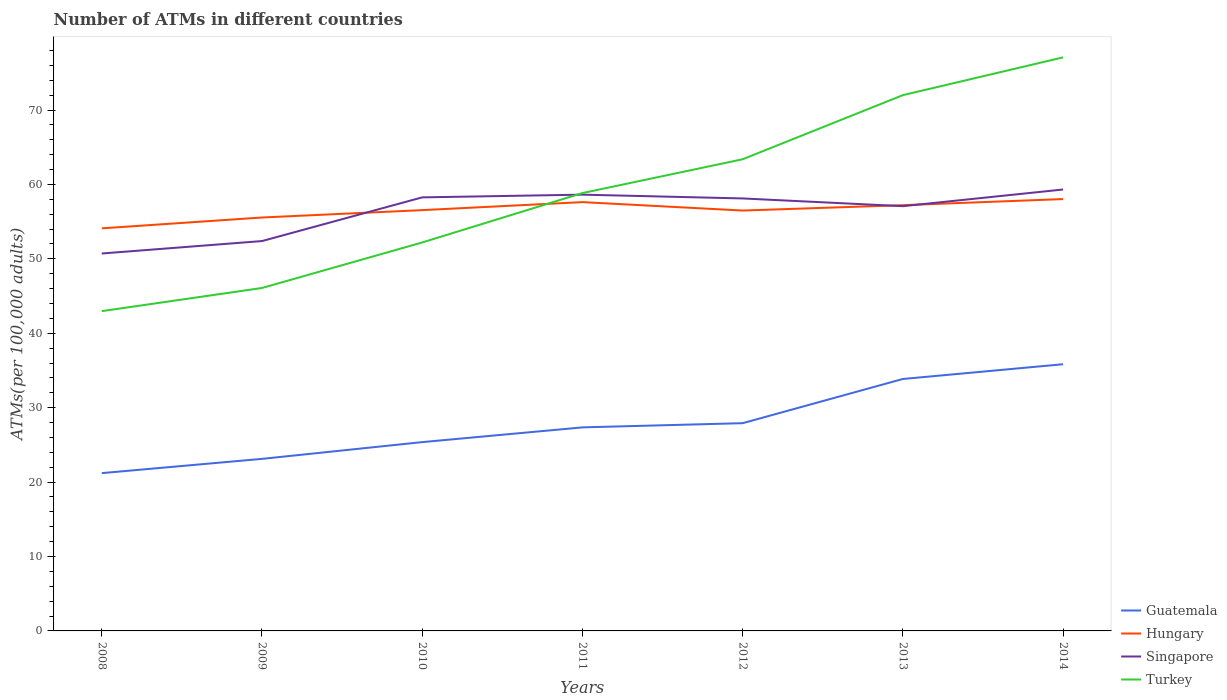How many different coloured lines are there?
Keep it short and to the point. 4. Is the number of lines equal to the number of legend labels?
Your answer should be very brief. Yes. Across all years, what is the maximum number of ATMs in Singapore?
Offer a very short reply. 50.72. In which year was the number of ATMs in Singapore maximum?
Ensure brevity in your answer.  2008. What is the total number of ATMs in Turkey in the graph?
Your answer should be compact. -19.8. What is the difference between the highest and the second highest number of ATMs in Hungary?
Keep it short and to the point. 3.93. Is the number of ATMs in Hungary strictly greater than the number of ATMs in Turkey over the years?
Provide a short and direct response. No. How many lines are there?
Keep it short and to the point. 4. How many years are there in the graph?
Give a very brief answer. 7. What is the difference between two consecutive major ticks on the Y-axis?
Offer a terse response. 10. Does the graph contain any zero values?
Give a very brief answer. No. Does the graph contain grids?
Your response must be concise. No. Where does the legend appear in the graph?
Provide a succinct answer. Bottom right. What is the title of the graph?
Keep it short and to the point. Number of ATMs in different countries. Does "Japan" appear as one of the legend labels in the graph?
Provide a succinct answer. No. What is the label or title of the Y-axis?
Your response must be concise. ATMs(per 100,0 adults). What is the ATMs(per 100,000 adults) of Guatemala in 2008?
Offer a terse response. 21.21. What is the ATMs(per 100,000 adults) in Hungary in 2008?
Your answer should be very brief. 54.1. What is the ATMs(per 100,000 adults) in Singapore in 2008?
Your answer should be compact. 50.72. What is the ATMs(per 100,000 adults) in Turkey in 2008?
Your answer should be very brief. 42.98. What is the ATMs(per 100,000 adults) in Guatemala in 2009?
Make the answer very short. 23.12. What is the ATMs(per 100,000 adults) in Hungary in 2009?
Offer a terse response. 55.56. What is the ATMs(per 100,000 adults) in Singapore in 2009?
Give a very brief answer. 52.39. What is the ATMs(per 100,000 adults) of Turkey in 2009?
Make the answer very short. 46.09. What is the ATMs(per 100,000 adults) of Guatemala in 2010?
Ensure brevity in your answer.  25.37. What is the ATMs(per 100,000 adults) of Hungary in 2010?
Make the answer very short. 56.55. What is the ATMs(per 100,000 adults) in Singapore in 2010?
Your response must be concise. 58.27. What is the ATMs(per 100,000 adults) of Turkey in 2010?
Ensure brevity in your answer.  52.21. What is the ATMs(per 100,000 adults) of Guatemala in 2011?
Ensure brevity in your answer.  27.35. What is the ATMs(per 100,000 adults) of Hungary in 2011?
Provide a short and direct response. 57.63. What is the ATMs(per 100,000 adults) of Singapore in 2011?
Your answer should be compact. 58.63. What is the ATMs(per 100,000 adults) in Turkey in 2011?
Your answer should be very brief. 58.84. What is the ATMs(per 100,000 adults) of Guatemala in 2012?
Keep it short and to the point. 27.92. What is the ATMs(per 100,000 adults) of Hungary in 2012?
Provide a short and direct response. 56.49. What is the ATMs(per 100,000 adults) of Singapore in 2012?
Your response must be concise. 58.12. What is the ATMs(per 100,000 adults) in Turkey in 2012?
Offer a very short reply. 63.39. What is the ATMs(per 100,000 adults) in Guatemala in 2013?
Ensure brevity in your answer.  33.86. What is the ATMs(per 100,000 adults) of Hungary in 2013?
Provide a short and direct response. 57.22. What is the ATMs(per 100,000 adults) in Singapore in 2013?
Offer a very short reply. 57.08. What is the ATMs(per 100,000 adults) of Turkey in 2013?
Ensure brevity in your answer.  72. What is the ATMs(per 100,000 adults) in Guatemala in 2014?
Your response must be concise. 35.84. What is the ATMs(per 100,000 adults) in Hungary in 2014?
Provide a succinct answer. 58.04. What is the ATMs(per 100,000 adults) of Singapore in 2014?
Your answer should be compact. 59.32. What is the ATMs(per 100,000 adults) in Turkey in 2014?
Offer a very short reply. 77.08. Across all years, what is the maximum ATMs(per 100,000 adults) in Guatemala?
Your response must be concise. 35.84. Across all years, what is the maximum ATMs(per 100,000 adults) in Hungary?
Ensure brevity in your answer.  58.04. Across all years, what is the maximum ATMs(per 100,000 adults) in Singapore?
Your answer should be very brief. 59.32. Across all years, what is the maximum ATMs(per 100,000 adults) of Turkey?
Your response must be concise. 77.08. Across all years, what is the minimum ATMs(per 100,000 adults) of Guatemala?
Ensure brevity in your answer.  21.21. Across all years, what is the minimum ATMs(per 100,000 adults) in Hungary?
Provide a succinct answer. 54.1. Across all years, what is the minimum ATMs(per 100,000 adults) in Singapore?
Offer a very short reply. 50.72. Across all years, what is the minimum ATMs(per 100,000 adults) of Turkey?
Provide a short and direct response. 42.98. What is the total ATMs(per 100,000 adults) in Guatemala in the graph?
Offer a terse response. 194.68. What is the total ATMs(per 100,000 adults) in Hungary in the graph?
Your response must be concise. 395.59. What is the total ATMs(per 100,000 adults) of Singapore in the graph?
Make the answer very short. 394.54. What is the total ATMs(per 100,000 adults) of Turkey in the graph?
Ensure brevity in your answer.  412.59. What is the difference between the ATMs(per 100,000 adults) in Guatemala in 2008 and that in 2009?
Offer a terse response. -1.92. What is the difference between the ATMs(per 100,000 adults) in Hungary in 2008 and that in 2009?
Give a very brief answer. -1.46. What is the difference between the ATMs(per 100,000 adults) of Singapore in 2008 and that in 2009?
Make the answer very short. -1.67. What is the difference between the ATMs(per 100,000 adults) in Turkey in 2008 and that in 2009?
Make the answer very short. -3.11. What is the difference between the ATMs(per 100,000 adults) of Guatemala in 2008 and that in 2010?
Offer a very short reply. -4.17. What is the difference between the ATMs(per 100,000 adults) of Hungary in 2008 and that in 2010?
Offer a very short reply. -2.45. What is the difference between the ATMs(per 100,000 adults) of Singapore in 2008 and that in 2010?
Ensure brevity in your answer.  -7.54. What is the difference between the ATMs(per 100,000 adults) in Turkey in 2008 and that in 2010?
Offer a terse response. -9.23. What is the difference between the ATMs(per 100,000 adults) of Guatemala in 2008 and that in 2011?
Provide a short and direct response. -6.15. What is the difference between the ATMs(per 100,000 adults) in Hungary in 2008 and that in 2011?
Provide a short and direct response. -3.52. What is the difference between the ATMs(per 100,000 adults) of Singapore in 2008 and that in 2011?
Provide a succinct answer. -7.91. What is the difference between the ATMs(per 100,000 adults) in Turkey in 2008 and that in 2011?
Make the answer very short. -15.87. What is the difference between the ATMs(per 100,000 adults) of Guatemala in 2008 and that in 2012?
Offer a very short reply. -6.71. What is the difference between the ATMs(per 100,000 adults) in Hungary in 2008 and that in 2012?
Give a very brief answer. -2.39. What is the difference between the ATMs(per 100,000 adults) of Singapore in 2008 and that in 2012?
Your answer should be very brief. -7.4. What is the difference between the ATMs(per 100,000 adults) of Turkey in 2008 and that in 2012?
Your answer should be very brief. -20.41. What is the difference between the ATMs(per 100,000 adults) in Guatemala in 2008 and that in 2013?
Ensure brevity in your answer.  -12.65. What is the difference between the ATMs(per 100,000 adults) in Hungary in 2008 and that in 2013?
Offer a very short reply. -3.11. What is the difference between the ATMs(per 100,000 adults) in Singapore in 2008 and that in 2013?
Keep it short and to the point. -6.36. What is the difference between the ATMs(per 100,000 adults) in Turkey in 2008 and that in 2013?
Your answer should be very brief. -29.03. What is the difference between the ATMs(per 100,000 adults) in Guatemala in 2008 and that in 2014?
Ensure brevity in your answer.  -14.63. What is the difference between the ATMs(per 100,000 adults) in Hungary in 2008 and that in 2014?
Your response must be concise. -3.93. What is the difference between the ATMs(per 100,000 adults) in Singapore in 2008 and that in 2014?
Offer a terse response. -8.6. What is the difference between the ATMs(per 100,000 adults) of Turkey in 2008 and that in 2014?
Offer a very short reply. -34.11. What is the difference between the ATMs(per 100,000 adults) of Guatemala in 2009 and that in 2010?
Offer a terse response. -2.25. What is the difference between the ATMs(per 100,000 adults) of Hungary in 2009 and that in 2010?
Offer a very short reply. -0.99. What is the difference between the ATMs(per 100,000 adults) in Singapore in 2009 and that in 2010?
Offer a terse response. -5.87. What is the difference between the ATMs(per 100,000 adults) of Turkey in 2009 and that in 2010?
Give a very brief answer. -6.12. What is the difference between the ATMs(per 100,000 adults) of Guatemala in 2009 and that in 2011?
Provide a short and direct response. -4.23. What is the difference between the ATMs(per 100,000 adults) in Hungary in 2009 and that in 2011?
Offer a terse response. -2.07. What is the difference between the ATMs(per 100,000 adults) of Singapore in 2009 and that in 2011?
Keep it short and to the point. -6.24. What is the difference between the ATMs(per 100,000 adults) in Turkey in 2009 and that in 2011?
Give a very brief answer. -12.75. What is the difference between the ATMs(per 100,000 adults) of Guatemala in 2009 and that in 2012?
Your answer should be compact. -4.8. What is the difference between the ATMs(per 100,000 adults) of Hungary in 2009 and that in 2012?
Provide a short and direct response. -0.93. What is the difference between the ATMs(per 100,000 adults) in Singapore in 2009 and that in 2012?
Provide a succinct answer. -5.73. What is the difference between the ATMs(per 100,000 adults) of Turkey in 2009 and that in 2012?
Your answer should be very brief. -17.3. What is the difference between the ATMs(per 100,000 adults) of Guatemala in 2009 and that in 2013?
Offer a very short reply. -10.74. What is the difference between the ATMs(per 100,000 adults) in Hungary in 2009 and that in 2013?
Give a very brief answer. -1.66. What is the difference between the ATMs(per 100,000 adults) of Singapore in 2009 and that in 2013?
Keep it short and to the point. -4.69. What is the difference between the ATMs(per 100,000 adults) in Turkey in 2009 and that in 2013?
Your answer should be compact. -25.91. What is the difference between the ATMs(per 100,000 adults) of Guatemala in 2009 and that in 2014?
Ensure brevity in your answer.  -12.72. What is the difference between the ATMs(per 100,000 adults) in Hungary in 2009 and that in 2014?
Your answer should be compact. -2.48. What is the difference between the ATMs(per 100,000 adults) in Singapore in 2009 and that in 2014?
Offer a very short reply. -6.93. What is the difference between the ATMs(per 100,000 adults) in Turkey in 2009 and that in 2014?
Your response must be concise. -30.99. What is the difference between the ATMs(per 100,000 adults) in Guatemala in 2010 and that in 2011?
Provide a succinct answer. -1.98. What is the difference between the ATMs(per 100,000 adults) in Hungary in 2010 and that in 2011?
Your answer should be compact. -1.08. What is the difference between the ATMs(per 100,000 adults) in Singapore in 2010 and that in 2011?
Your answer should be very brief. -0.36. What is the difference between the ATMs(per 100,000 adults) in Turkey in 2010 and that in 2011?
Give a very brief answer. -6.64. What is the difference between the ATMs(per 100,000 adults) in Guatemala in 2010 and that in 2012?
Your response must be concise. -2.55. What is the difference between the ATMs(per 100,000 adults) of Hungary in 2010 and that in 2012?
Make the answer very short. 0.06. What is the difference between the ATMs(per 100,000 adults) in Singapore in 2010 and that in 2012?
Ensure brevity in your answer.  0.14. What is the difference between the ATMs(per 100,000 adults) in Turkey in 2010 and that in 2012?
Offer a terse response. -11.18. What is the difference between the ATMs(per 100,000 adults) in Guatemala in 2010 and that in 2013?
Provide a short and direct response. -8.49. What is the difference between the ATMs(per 100,000 adults) of Hungary in 2010 and that in 2013?
Offer a very short reply. -0.67. What is the difference between the ATMs(per 100,000 adults) of Singapore in 2010 and that in 2013?
Your answer should be compact. 1.18. What is the difference between the ATMs(per 100,000 adults) of Turkey in 2010 and that in 2013?
Ensure brevity in your answer.  -19.8. What is the difference between the ATMs(per 100,000 adults) in Guatemala in 2010 and that in 2014?
Offer a very short reply. -10.47. What is the difference between the ATMs(per 100,000 adults) of Hungary in 2010 and that in 2014?
Provide a succinct answer. -1.49. What is the difference between the ATMs(per 100,000 adults) of Singapore in 2010 and that in 2014?
Offer a terse response. -1.06. What is the difference between the ATMs(per 100,000 adults) in Turkey in 2010 and that in 2014?
Offer a terse response. -24.88. What is the difference between the ATMs(per 100,000 adults) in Guatemala in 2011 and that in 2012?
Keep it short and to the point. -0.56. What is the difference between the ATMs(per 100,000 adults) in Hungary in 2011 and that in 2012?
Offer a very short reply. 1.13. What is the difference between the ATMs(per 100,000 adults) of Singapore in 2011 and that in 2012?
Your response must be concise. 0.51. What is the difference between the ATMs(per 100,000 adults) in Turkey in 2011 and that in 2012?
Give a very brief answer. -4.54. What is the difference between the ATMs(per 100,000 adults) in Guatemala in 2011 and that in 2013?
Provide a short and direct response. -6.5. What is the difference between the ATMs(per 100,000 adults) in Hungary in 2011 and that in 2013?
Give a very brief answer. 0.41. What is the difference between the ATMs(per 100,000 adults) in Singapore in 2011 and that in 2013?
Make the answer very short. 1.55. What is the difference between the ATMs(per 100,000 adults) in Turkey in 2011 and that in 2013?
Keep it short and to the point. -13.16. What is the difference between the ATMs(per 100,000 adults) of Guatemala in 2011 and that in 2014?
Give a very brief answer. -8.49. What is the difference between the ATMs(per 100,000 adults) in Hungary in 2011 and that in 2014?
Keep it short and to the point. -0.41. What is the difference between the ATMs(per 100,000 adults) in Singapore in 2011 and that in 2014?
Your answer should be compact. -0.69. What is the difference between the ATMs(per 100,000 adults) in Turkey in 2011 and that in 2014?
Make the answer very short. -18.24. What is the difference between the ATMs(per 100,000 adults) in Guatemala in 2012 and that in 2013?
Make the answer very short. -5.94. What is the difference between the ATMs(per 100,000 adults) of Hungary in 2012 and that in 2013?
Offer a terse response. -0.72. What is the difference between the ATMs(per 100,000 adults) in Singapore in 2012 and that in 2013?
Offer a very short reply. 1.04. What is the difference between the ATMs(per 100,000 adults) of Turkey in 2012 and that in 2013?
Your answer should be compact. -8.62. What is the difference between the ATMs(per 100,000 adults) of Guatemala in 2012 and that in 2014?
Give a very brief answer. -7.92. What is the difference between the ATMs(per 100,000 adults) of Hungary in 2012 and that in 2014?
Provide a succinct answer. -1.54. What is the difference between the ATMs(per 100,000 adults) of Singapore in 2012 and that in 2014?
Offer a terse response. -1.2. What is the difference between the ATMs(per 100,000 adults) of Turkey in 2012 and that in 2014?
Offer a very short reply. -13.69. What is the difference between the ATMs(per 100,000 adults) of Guatemala in 2013 and that in 2014?
Give a very brief answer. -1.98. What is the difference between the ATMs(per 100,000 adults) of Hungary in 2013 and that in 2014?
Your answer should be very brief. -0.82. What is the difference between the ATMs(per 100,000 adults) of Singapore in 2013 and that in 2014?
Offer a very short reply. -2.24. What is the difference between the ATMs(per 100,000 adults) of Turkey in 2013 and that in 2014?
Provide a succinct answer. -5.08. What is the difference between the ATMs(per 100,000 adults) in Guatemala in 2008 and the ATMs(per 100,000 adults) in Hungary in 2009?
Keep it short and to the point. -34.35. What is the difference between the ATMs(per 100,000 adults) in Guatemala in 2008 and the ATMs(per 100,000 adults) in Singapore in 2009?
Your answer should be very brief. -31.19. What is the difference between the ATMs(per 100,000 adults) in Guatemala in 2008 and the ATMs(per 100,000 adults) in Turkey in 2009?
Give a very brief answer. -24.88. What is the difference between the ATMs(per 100,000 adults) in Hungary in 2008 and the ATMs(per 100,000 adults) in Singapore in 2009?
Make the answer very short. 1.71. What is the difference between the ATMs(per 100,000 adults) of Hungary in 2008 and the ATMs(per 100,000 adults) of Turkey in 2009?
Your answer should be very brief. 8.01. What is the difference between the ATMs(per 100,000 adults) in Singapore in 2008 and the ATMs(per 100,000 adults) in Turkey in 2009?
Your answer should be compact. 4.63. What is the difference between the ATMs(per 100,000 adults) in Guatemala in 2008 and the ATMs(per 100,000 adults) in Hungary in 2010?
Your response must be concise. -35.34. What is the difference between the ATMs(per 100,000 adults) in Guatemala in 2008 and the ATMs(per 100,000 adults) in Singapore in 2010?
Offer a very short reply. -37.06. What is the difference between the ATMs(per 100,000 adults) of Guatemala in 2008 and the ATMs(per 100,000 adults) of Turkey in 2010?
Offer a very short reply. -31. What is the difference between the ATMs(per 100,000 adults) of Hungary in 2008 and the ATMs(per 100,000 adults) of Singapore in 2010?
Offer a very short reply. -4.16. What is the difference between the ATMs(per 100,000 adults) of Hungary in 2008 and the ATMs(per 100,000 adults) of Turkey in 2010?
Keep it short and to the point. 1.9. What is the difference between the ATMs(per 100,000 adults) of Singapore in 2008 and the ATMs(per 100,000 adults) of Turkey in 2010?
Offer a very short reply. -1.48. What is the difference between the ATMs(per 100,000 adults) of Guatemala in 2008 and the ATMs(per 100,000 adults) of Hungary in 2011?
Your answer should be compact. -36.42. What is the difference between the ATMs(per 100,000 adults) of Guatemala in 2008 and the ATMs(per 100,000 adults) of Singapore in 2011?
Your answer should be very brief. -37.42. What is the difference between the ATMs(per 100,000 adults) of Guatemala in 2008 and the ATMs(per 100,000 adults) of Turkey in 2011?
Your response must be concise. -37.64. What is the difference between the ATMs(per 100,000 adults) in Hungary in 2008 and the ATMs(per 100,000 adults) in Singapore in 2011?
Your response must be concise. -4.53. What is the difference between the ATMs(per 100,000 adults) of Hungary in 2008 and the ATMs(per 100,000 adults) of Turkey in 2011?
Your answer should be very brief. -4.74. What is the difference between the ATMs(per 100,000 adults) of Singapore in 2008 and the ATMs(per 100,000 adults) of Turkey in 2011?
Give a very brief answer. -8.12. What is the difference between the ATMs(per 100,000 adults) of Guatemala in 2008 and the ATMs(per 100,000 adults) of Hungary in 2012?
Your answer should be compact. -35.29. What is the difference between the ATMs(per 100,000 adults) of Guatemala in 2008 and the ATMs(per 100,000 adults) of Singapore in 2012?
Keep it short and to the point. -36.92. What is the difference between the ATMs(per 100,000 adults) in Guatemala in 2008 and the ATMs(per 100,000 adults) in Turkey in 2012?
Offer a terse response. -42.18. What is the difference between the ATMs(per 100,000 adults) of Hungary in 2008 and the ATMs(per 100,000 adults) of Singapore in 2012?
Offer a terse response. -4.02. What is the difference between the ATMs(per 100,000 adults) in Hungary in 2008 and the ATMs(per 100,000 adults) in Turkey in 2012?
Ensure brevity in your answer.  -9.28. What is the difference between the ATMs(per 100,000 adults) in Singapore in 2008 and the ATMs(per 100,000 adults) in Turkey in 2012?
Give a very brief answer. -12.66. What is the difference between the ATMs(per 100,000 adults) in Guatemala in 2008 and the ATMs(per 100,000 adults) in Hungary in 2013?
Your response must be concise. -36.01. What is the difference between the ATMs(per 100,000 adults) of Guatemala in 2008 and the ATMs(per 100,000 adults) of Singapore in 2013?
Offer a very short reply. -35.88. What is the difference between the ATMs(per 100,000 adults) of Guatemala in 2008 and the ATMs(per 100,000 adults) of Turkey in 2013?
Provide a short and direct response. -50.8. What is the difference between the ATMs(per 100,000 adults) of Hungary in 2008 and the ATMs(per 100,000 adults) of Singapore in 2013?
Make the answer very short. -2.98. What is the difference between the ATMs(per 100,000 adults) in Hungary in 2008 and the ATMs(per 100,000 adults) in Turkey in 2013?
Keep it short and to the point. -17.9. What is the difference between the ATMs(per 100,000 adults) of Singapore in 2008 and the ATMs(per 100,000 adults) of Turkey in 2013?
Keep it short and to the point. -21.28. What is the difference between the ATMs(per 100,000 adults) in Guatemala in 2008 and the ATMs(per 100,000 adults) in Hungary in 2014?
Provide a short and direct response. -36.83. What is the difference between the ATMs(per 100,000 adults) of Guatemala in 2008 and the ATMs(per 100,000 adults) of Singapore in 2014?
Your answer should be very brief. -38.12. What is the difference between the ATMs(per 100,000 adults) of Guatemala in 2008 and the ATMs(per 100,000 adults) of Turkey in 2014?
Offer a terse response. -55.88. What is the difference between the ATMs(per 100,000 adults) of Hungary in 2008 and the ATMs(per 100,000 adults) of Singapore in 2014?
Provide a succinct answer. -5.22. What is the difference between the ATMs(per 100,000 adults) in Hungary in 2008 and the ATMs(per 100,000 adults) in Turkey in 2014?
Keep it short and to the point. -22.98. What is the difference between the ATMs(per 100,000 adults) in Singapore in 2008 and the ATMs(per 100,000 adults) in Turkey in 2014?
Ensure brevity in your answer.  -26.36. What is the difference between the ATMs(per 100,000 adults) in Guatemala in 2009 and the ATMs(per 100,000 adults) in Hungary in 2010?
Your answer should be very brief. -33.43. What is the difference between the ATMs(per 100,000 adults) of Guatemala in 2009 and the ATMs(per 100,000 adults) of Singapore in 2010?
Make the answer very short. -35.14. What is the difference between the ATMs(per 100,000 adults) of Guatemala in 2009 and the ATMs(per 100,000 adults) of Turkey in 2010?
Offer a very short reply. -29.08. What is the difference between the ATMs(per 100,000 adults) in Hungary in 2009 and the ATMs(per 100,000 adults) in Singapore in 2010?
Keep it short and to the point. -2.71. What is the difference between the ATMs(per 100,000 adults) of Hungary in 2009 and the ATMs(per 100,000 adults) of Turkey in 2010?
Give a very brief answer. 3.35. What is the difference between the ATMs(per 100,000 adults) of Singapore in 2009 and the ATMs(per 100,000 adults) of Turkey in 2010?
Provide a short and direct response. 0.19. What is the difference between the ATMs(per 100,000 adults) in Guatemala in 2009 and the ATMs(per 100,000 adults) in Hungary in 2011?
Provide a succinct answer. -34.5. What is the difference between the ATMs(per 100,000 adults) in Guatemala in 2009 and the ATMs(per 100,000 adults) in Singapore in 2011?
Keep it short and to the point. -35.51. What is the difference between the ATMs(per 100,000 adults) in Guatemala in 2009 and the ATMs(per 100,000 adults) in Turkey in 2011?
Your answer should be compact. -35.72. What is the difference between the ATMs(per 100,000 adults) of Hungary in 2009 and the ATMs(per 100,000 adults) of Singapore in 2011?
Your answer should be very brief. -3.07. What is the difference between the ATMs(per 100,000 adults) of Hungary in 2009 and the ATMs(per 100,000 adults) of Turkey in 2011?
Make the answer very short. -3.28. What is the difference between the ATMs(per 100,000 adults) of Singapore in 2009 and the ATMs(per 100,000 adults) of Turkey in 2011?
Provide a short and direct response. -6.45. What is the difference between the ATMs(per 100,000 adults) in Guatemala in 2009 and the ATMs(per 100,000 adults) in Hungary in 2012?
Provide a succinct answer. -33.37. What is the difference between the ATMs(per 100,000 adults) of Guatemala in 2009 and the ATMs(per 100,000 adults) of Singapore in 2012?
Provide a succinct answer. -35. What is the difference between the ATMs(per 100,000 adults) of Guatemala in 2009 and the ATMs(per 100,000 adults) of Turkey in 2012?
Your answer should be compact. -40.26. What is the difference between the ATMs(per 100,000 adults) of Hungary in 2009 and the ATMs(per 100,000 adults) of Singapore in 2012?
Ensure brevity in your answer.  -2.56. What is the difference between the ATMs(per 100,000 adults) in Hungary in 2009 and the ATMs(per 100,000 adults) in Turkey in 2012?
Your answer should be compact. -7.83. What is the difference between the ATMs(per 100,000 adults) of Singapore in 2009 and the ATMs(per 100,000 adults) of Turkey in 2012?
Your answer should be compact. -10.99. What is the difference between the ATMs(per 100,000 adults) in Guatemala in 2009 and the ATMs(per 100,000 adults) in Hungary in 2013?
Your response must be concise. -34.09. What is the difference between the ATMs(per 100,000 adults) in Guatemala in 2009 and the ATMs(per 100,000 adults) in Singapore in 2013?
Your response must be concise. -33.96. What is the difference between the ATMs(per 100,000 adults) of Guatemala in 2009 and the ATMs(per 100,000 adults) of Turkey in 2013?
Ensure brevity in your answer.  -48.88. What is the difference between the ATMs(per 100,000 adults) in Hungary in 2009 and the ATMs(per 100,000 adults) in Singapore in 2013?
Offer a terse response. -1.52. What is the difference between the ATMs(per 100,000 adults) in Hungary in 2009 and the ATMs(per 100,000 adults) in Turkey in 2013?
Your answer should be very brief. -16.44. What is the difference between the ATMs(per 100,000 adults) of Singapore in 2009 and the ATMs(per 100,000 adults) of Turkey in 2013?
Provide a short and direct response. -19.61. What is the difference between the ATMs(per 100,000 adults) of Guatemala in 2009 and the ATMs(per 100,000 adults) of Hungary in 2014?
Your response must be concise. -34.92. What is the difference between the ATMs(per 100,000 adults) in Guatemala in 2009 and the ATMs(per 100,000 adults) in Singapore in 2014?
Your answer should be compact. -36.2. What is the difference between the ATMs(per 100,000 adults) of Guatemala in 2009 and the ATMs(per 100,000 adults) of Turkey in 2014?
Provide a short and direct response. -53.96. What is the difference between the ATMs(per 100,000 adults) in Hungary in 2009 and the ATMs(per 100,000 adults) in Singapore in 2014?
Your answer should be very brief. -3.76. What is the difference between the ATMs(per 100,000 adults) in Hungary in 2009 and the ATMs(per 100,000 adults) in Turkey in 2014?
Make the answer very short. -21.52. What is the difference between the ATMs(per 100,000 adults) of Singapore in 2009 and the ATMs(per 100,000 adults) of Turkey in 2014?
Make the answer very short. -24.69. What is the difference between the ATMs(per 100,000 adults) of Guatemala in 2010 and the ATMs(per 100,000 adults) of Hungary in 2011?
Offer a very short reply. -32.25. What is the difference between the ATMs(per 100,000 adults) of Guatemala in 2010 and the ATMs(per 100,000 adults) of Singapore in 2011?
Provide a succinct answer. -33.26. What is the difference between the ATMs(per 100,000 adults) in Guatemala in 2010 and the ATMs(per 100,000 adults) in Turkey in 2011?
Offer a terse response. -33.47. What is the difference between the ATMs(per 100,000 adults) of Hungary in 2010 and the ATMs(per 100,000 adults) of Singapore in 2011?
Your answer should be compact. -2.08. What is the difference between the ATMs(per 100,000 adults) in Hungary in 2010 and the ATMs(per 100,000 adults) in Turkey in 2011?
Your answer should be compact. -2.29. What is the difference between the ATMs(per 100,000 adults) of Singapore in 2010 and the ATMs(per 100,000 adults) of Turkey in 2011?
Keep it short and to the point. -0.58. What is the difference between the ATMs(per 100,000 adults) in Guatemala in 2010 and the ATMs(per 100,000 adults) in Hungary in 2012?
Provide a succinct answer. -31.12. What is the difference between the ATMs(per 100,000 adults) of Guatemala in 2010 and the ATMs(per 100,000 adults) of Singapore in 2012?
Give a very brief answer. -32.75. What is the difference between the ATMs(per 100,000 adults) of Guatemala in 2010 and the ATMs(per 100,000 adults) of Turkey in 2012?
Ensure brevity in your answer.  -38.01. What is the difference between the ATMs(per 100,000 adults) in Hungary in 2010 and the ATMs(per 100,000 adults) in Singapore in 2012?
Ensure brevity in your answer.  -1.57. What is the difference between the ATMs(per 100,000 adults) in Hungary in 2010 and the ATMs(per 100,000 adults) in Turkey in 2012?
Give a very brief answer. -6.84. What is the difference between the ATMs(per 100,000 adults) of Singapore in 2010 and the ATMs(per 100,000 adults) of Turkey in 2012?
Make the answer very short. -5.12. What is the difference between the ATMs(per 100,000 adults) of Guatemala in 2010 and the ATMs(per 100,000 adults) of Hungary in 2013?
Your response must be concise. -31.84. What is the difference between the ATMs(per 100,000 adults) in Guatemala in 2010 and the ATMs(per 100,000 adults) in Singapore in 2013?
Provide a short and direct response. -31.71. What is the difference between the ATMs(per 100,000 adults) in Guatemala in 2010 and the ATMs(per 100,000 adults) in Turkey in 2013?
Give a very brief answer. -46.63. What is the difference between the ATMs(per 100,000 adults) of Hungary in 2010 and the ATMs(per 100,000 adults) of Singapore in 2013?
Your response must be concise. -0.53. What is the difference between the ATMs(per 100,000 adults) in Hungary in 2010 and the ATMs(per 100,000 adults) in Turkey in 2013?
Give a very brief answer. -15.45. What is the difference between the ATMs(per 100,000 adults) of Singapore in 2010 and the ATMs(per 100,000 adults) of Turkey in 2013?
Give a very brief answer. -13.74. What is the difference between the ATMs(per 100,000 adults) in Guatemala in 2010 and the ATMs(per 100,000 adults) in Hungary in 2014?
Your answer should be compact. -32.66. What is the difference between the ATMs(per 100,000 adults) in Guatemala in 2010 and the ATMs(per 100,000 adults) in Singapore in 2014?
Your answer should be compact. -33.95. What is the difference between the ATMs(per 100,000 adults) of Guatemala in 2010 and the ATMs(per 100,000 adults) of Turkey in 2014?
Provide a short and direct response. -51.71. What is the difference between the ATMs(per 100,000 adults) in Hungary in 2010 and the ATMs(per 100,000 adults) in Singapore in 2014?
Your answer should be compact. -2.77. What is the difference between the ATMs(per 100,000 adults) in Hungary in 2010 and the ATMs(per 100,000 adults) in Turkey in 2014?
Provide a short and direct response. -20.53. What is the difference between the ATMs(per 100,000 adults) in Singapore in 2010 and the ATMs(per 100,000 adults) in Turkey in 2014?
Offer a terse response. -18.82. What is the difference between the ATMs(per 100,000 adults) in Guatemala in 2011 and the ATMs(per 100,000 adults) in Hungary in 2012?
Provide a succinct answer. -29.14. What is the difference between the ATMs(per 100,000 adults) in Guatemala in 2011 and the ATMs(per 100,000 adults) in Singapore in 2012?
Your answer should be very brief. -30.77. What is the difference between the ATMs(per 100,000 adults) in Guatemala in 2011 and the ATMs(per 100,000 adults) in Turkey in 2012?
Provide a short and direct response. -36.03. What is the difference between the ATMs(per 100,000 adults) of Hungary in 2011 and the ATMs(per 100,000 adults) of Singapore in 2012?
Offer a terse response. -0.5. What is the difference between the ATMs(per 100,000 adults) of Hungary in 2011 and the ATMs(per 100,000 adults) of Turkey in 2012?
Ensure brevity in your answer.  -5.76. What is the difference between the ATMs(per 100,000 adults) in Singapore in 2011 and the ATMs(per 100,000 adults) in Turkey in 2012?
Your answer should be very brief. -4.76. What is the difference between the ATMs(per 100,000 adults) of Guatemala in 2011 and the ATMs(per 100,000 adults) of Hungary in 2013?
Ensure brevity in your answer.  -29.86. What is the difference between the ATMs(per 100,000 adults) in Guatemala in 2011 and the ATMs(per 100,000 adults) in Singapore in 2013?
Provide a succinct answer. -29.73. What is the difference between the ATMs(per 100,000 adults) in Guatemala in 2011 and the ATMs(per 100,000 adults) in Turkey in 2013?
Offer a very short reply. -44.65. What is the difference between the ATMs(per 100,000 adults) in Hungary in 2011 and the ATMs(per 100,000 adults) in Singapore in 2013?
Provide a succinct answer. 0.54. What is the difference between the ATMs(per 100,000 adults) of Hungary in 2011 and the ATMs(per 100,000 adults) of Turkey in 2013?
Offer a very short reply. -14.38. What is the difference between the ATMs(per 100,000 adults) of Singapore in 2011 and the ATMs(per 100,000 adults) of Turkey in 2013?
Your response must be concise. -13.37. What is the difference between the ATMs(per 100,000 adults) of Guatemala in 2011 and the ATMs(per 100,000 adults) of Hungary in 2014?
Your answer should be compact. -30.68. What is the difference between the ATMs(per 100,000 adults) in Guatemala in 2011 and the ATMs(per 100,000 adults) in Singapore in 2014?
Offer a very short reply. -31.97. What is the difference between the ATMs(per 100,000 adults) of Guatemala in 2011 and the ATMs(per 100,000 adults) of Turkey in 2014?
Provide a succinct answer. -49.73. What is the difference between the ATMs(per 100,000 adults) in Hungary in 2011 and the ATMs(per 100,000 adults) in Singapore in 2014?
Ensure brevity in your answer.  -1.7. What is the difference between the ATMs(per 100,000 adults) in Hungary in 2011 and the ATMs(per 100,000 adults) in Turkey in 2014?
Keep it short and to the point. -19.45. What is the difference between the ATMs(per 100,000 adults) of Singapore in 2011 and the ATMs(per 100,000 adults) of Turkey in 2014?
Your answer should be very brief. -18.45. What is the difference between the ATMs(per 100,000 adults) of Guatemala in 2012 and the ATMs(per 100,000 adults) of Hungary in 2013?
Your answer should be very brief. -29.3. What is the difference between the ATMs(per 100,000 adults) of Guatemala in 2012 and the ATMs(per 100,000 adults) of Singapore in 2013?
Provide a succinct answer. -29.16. What is the difference between the ATMs(per 100,000 adults) of Guatemala in 2012 and the ATMs(per 100,000 adults) of Turkey in 2013?
Your answer should be compact. -44.08. What is the difference between the ATMs(per 100,000 adults) of Hungary in 2012 and the ATMs(per 100,000 adults) of Singapore in 2013?
Give a very brief answer. -0.59. What is the difference between the ATMs(per 100,000 adults) in Hungary in 2012 and the ATMs(per 100,000 adults) in Turkey in 2013?
Your response must be concise. -15.51. What is the difference between the ATMs(per 100,000 adults) of Singapore in 2012 and the ATMs(per 100,000 adults) of Turkey in 2013?
Provide a short and direct response. -13.88. What is the difference between the ATMs(per 100,000 adults) of Guatemala in 2012 and the ATMs(per 100,000 adults) of Hungary in 2014?
Give a very brief answer. -30.12. What is the difference between the ATMs(per 100,000 adults) of Guatemala in 2012 and the ATMs(per 100,000 adults) of Singapore in 2014?
Provide a succinct answer. -31.4. What is the difference between the ATMs(per 100,000 adults) in Guatemala in 2012 and the ATMs(per 100,000 adults) in Turkey in 2014?
Give a very brief answer. -49.16. What is the difference between the ATMs(per 100,000 adults) in Hungary in 2012 and the ATMs(per 100,000 adults) in Singapore in 2014?
Make the answer very short. -2.83. What is the difference between the ATMs(per 100,000 adults) in Hungary in 2012 and the ATMs(per 100,000 adults) in Turkey in 2014?
Ensure brevity in your answer.  -20.59. What is the difference between the ATMs(per 100,000 adults) of Singapore in 2012 and the ATMs(per 100,000 adults) of Turkey in 2014?
Offer a very short reply. -18.96. What is the difference between the ATMs(per 100,000 adults) of Guatemala in 2013 and the ATMs(per 100,000 adults) of Hungary in 2014?
Your answer should be very brief. -24.18. What is the difference between the ATMs(per 100,000 adults) in Guatemala in 2013 and the ATMs(per 100,000 adults) in Singapore in 2014?
Your response must be concise. -25.46. What is the difference between the ATMs(per 100,000 adults) of Guatemala in 2013 and the ATMs(per 100,000 adults) of Turkey in 2014?
Keep it short and to the point. -43.22. What is the difference between the ATMs(per 100,000 adults) of Hungary in 2013 and the ATMs(per 100,000 adults) of Singapore in 2014?
Provide a short and direct response. -2.11. What is the difference between the ATMs(per 100,000 adults) in Hungary in 2013 and the ATMs(per 100,000 adults) in Turkey in 2014?
Ensure brevity in your answer.  -19.86. What is the difference between the ATMs(per 100,000 adults) of Singapore in 2013 and the ATMs(per 100,000 adults) of Turkey in 2014?
Offer a terse response. -20. What is the average ATMs(per 100,000 adults) in Guatemala per year?
Keep it short and to the point. 27.81. What is the average ATMs(per 100,000 adults) of Hungary per year?
Give a very brief answer. 56.51. What is the average ATMs(per 100,000 adults) of Singapore per year?
Provide a succinct answer. 56.36. What is the average ATMs(per 100,000 adults) in Turkey per year?
Offer a terse response. 58.94. In the year 2008, what is the difference between the ATMs(per 100,000 adults) in Guatemala and ATMs(per 100,000 adults) in Hungary?
Provide a short and direct response. -32.9. In the year 2008, what is the difference between the ATMs(per 100,000 adults) in Guatemala and ATMs(per 100,000 adults) in Singapore?
Offer a terse response. -29.52. In the year 2008, what is the difference between the ATMs(per 100,000 adults) in Guatemala and ATMs(per 100,000 adults) in Turkey?
Give a very brief answer. -21.77. In the year 2008, what is the difference between the ATMs(per 100,000 adults) of Hungary and ATMs(per 100,000 adults) of Singapore?
Keep it short and to the point. 3.38. In the year 2008, what is the difference between the ATMs(per 100,000 adults) of Hungary and ATMs(per 100,000 adults) of Turkey?
Offer a very short reply. 11.13. In the year 2008, what is the difference between the ATMs(per 100,000 adults) of Singapore and ATMs(per 100,000 adults) of Turkey?
Offer a very short reply. 7.75. In the year 2009, what is the difference between the ATMs(per 100,000 adults) of Guatemala and ATMs(per 100,000 adults) of Hungary?
Offer a terse response. -32.44. In the year 2009, what is the difference between the ATMs(per 100,000 adults) in Guatemala and ATMs(per 100,000 adults) in Singapore?
Your answer should be compact. -29.27. In the year 2009, what is the difference between the ATMs(per 100,000 adults) of Guatemala and ATMs(per 100,000 adults) of Turkey?
Offer a terse response. -22.97. In the year 2009, what is the difference between the ATMs(per 100,000 adults) in Hungary and ATMs(per 100,000 adults) in Singapore?
Keep it short and to the point. 3.17. In the year 2009, what is the difference between the ATMs(per 100,000 adults) in Hungary and ATMs(per 100,000 adults) in Turkey?
Your answer should be very brief. 9.47. In the year 2009, what is the difference between the ATMs(per 100,000 adults) in Singapore and ATMs(per 100,000 adults) in Turkey?
Give a very brief answer. 6.3. In the year 2010, what is the difference between the ATMs(per 100,000 adults) in Guatemala and ATMs(per 100,000 adults) in Hungary?
Your answer should be very brief. -31.18. In the year 2010, what is the difference between the ATMs(per 100,000 adults) of Guatemala and ATMs(per 100,000 adults) of Singapore?
Provide a short and direct response. -32.89. In the year 2010, what is the difference between the ATMs(per 100,000 adults) of Guatemala and ATMs(per 100,000 adults) of Turkey?
Keep it short and to the point. -26.83. In the year 2010, what is the difference between the ATMs(per 100,000 adults) in Hungary and ATMs(per 100,000 adults) in Singapore?
Your response must be concise. -1.71. In the year 2010, what is the difference between the ATMs(per 100,000 adults) in Hungary and ATMs(per 100,000 adults) in Turkey?
Offer a terse response. 4.35. In the year 2010, what is the difference between the ATMs(per 100,000 adults) in Singapore and ATMs(per 100,000 adults) in Turkey?
Keep it short and to the point. 6.06. In the year 2011, what is the difference between the ATMs(per 100,000 adults) in Guatemala and ATMs(per 100,000 adults) in Hungary?
Offer a terse response. -30.27. In the year 2011, what is the difference between the ATMs(per 100,000 adults) of Guatemala and ATMs(per 100,000 adults) of Singapore?
Keep it short and to the point. -31.28. In the year 2011, what is the difference between the ATMs(per 100,000 adults) of Guatemala and ATMs(per 100,000 adults) of Turkey?
Ensure brevity in your answer.  -31.49. In the year 2011, what is the difference between the ATMs(per 100,000 adults) of Hungary and ATMs(per 100,000 adults) of Singapore?
Your response must be concise. -1. In the year 2011, what is the difference between the ATMs(per 100,000 adults) of Hungary and ATMs(per 100,000 adults) of Turkey?
Your response must be concise. -1.22. In the year 2011, what is the difference between the ATMs(per 100,000 adults) in Singapore and ATMs(per 100,000 adults) in Turkey?
Provide a succinct answer. -0.21. In the year 2012, what is the difference between the ATMs(per 100,000 adults) of Guatemala and ATMs(per 100,000 adults) of Hungary?
Offer a very short reply. -28.58. In the year 2012, what is the difference between the ATMs(per 100,000 adults) in Guatemala and ATMs(per 100,000 adults) in Singapore?
Your response must be concise. -30.2. In the year 2012, what is the difference between the ATMs(per 100,000 adults) in Guatemala and ATMs(per 100,000 adults) in Turkey?
Keep it short and to the point. -35.47. In the year 2012, what is the difference between the ATMs(per 100,000 adults) in Hungary and ATMs(per 100,000 adults) in Singapore?
Your answer should be compact. -1.63. In the year 2012, what is the difference between the ATMs(per 100,000 adults) of Hungary and ATMs(per 100,000 adults) of Turkey?
Keep it short and to the point. -6.89. In the year 2012, what is the difference between the ATMs(per 100,000 adults) of Singapore and ATMs(per 100,000 adults) of Turkey?
Provide a short and direct response. -5.26. In the year 2013, what is the difference between the ATMs(per 100,000 adults) in Guatemala and ATMs(per 100,000 adults) in Hungary?
Keep it short and to the point. -23.36. In the year 2013, what is the difference between the ATMs(per 100,000 adults) of Guatemala and ATMs(per 100,000 adults) of Singapore?
Your answer should be compact. -23.22. In the year 2013, what is the difference between the ATMs(per 100,000 adults) in Guatemala and ATMs(per 100,000 adults) in Turkey?
Provide a succinct answer. -38.14. In the year 2013, what is the difference between the ATMs(per 100,000 adults) of Hungary and ATMs(per 100,000 adults) of Singapore?
Keep it short and to the point. 0.13. In the year 2013, what is the difference between the ATMs(per 100,000 adults) in Hungary and ATMs(per 100,000 adults) in Turkey?
Your answer should be compact. -14.79. In the year 2013, what is the difference between the ATMs(per 100,000 adults) of Singapore and ATMs(per 100,000 adults) of Turkey?
Make the answer very short. -14.92. In the year 2014, what is the difference between the ATMs(per 100,000 adults) in Guatemala and ATMs(per 100,000 adults) in Hungary?
Keep it short and to the point. -22.2. In the year 2014, what is the difference between the ATMs(per 100,000 adults) of Guatemala and ATMs(per 100,000 adults) of Singapore?
Ensure brevity in your answer.  -23.48. In the year 2014, what is the difference between the ATMs(per 100,000 adults) of Guatemala and ATMs(per 100,000 adults) of Turkey?
Your response must be concise. -41.24. In the year 2014, what is the difference between the ATMs(per 100,000 adults) in Hungary and ATMs(per 100,000 adults) in Singapore?
Offer a very short reply. -1.28. In the year 2014, what is the difference between the ATMs(per 100,000 adults) in Hungary and ATMs(per 100,000 adults) in Turkey?
Provide a succinct answer. -19.04. In the year 2014, what is the difference between the ATMs(per 100,000 adults) in Singapore and ATMs(per 100,000 adults) in Turkey?
Your answer should be very brief. -17.76. What is the ratio of the ATMs(per 100,000 adults) in Guatemala in 2008 to that in 2009?
Offer a terse response. 0.92. What is the ratio of the ATMs(per 100,000 adults) in Hungary in 2008 to that in 2009?
Provide a succinct answer. 0.97. What is the ratio of the ATMs(per 100,000 adults) in Singapore in 2008 to that in 2009?
Offer a very short reply. 0.97. What is the ratio of the ATMs(per 100,000 adults) of Turkey in 2008 to that in 2009?
Ensure brevity in your answer.  0.93. What is the ratio of the ATMs(per 100,000 adults) in Guatemala in 2008 to that in 2010?
Your response must be concise. 0.84. What is the ratio of the ATMs(per 100,000 adults) of Hungary in 2008 to that in 2010?
Ensure brevity in your answer.  0.96. What is the ratio of the ATMs(per 100,000 adults) of Singapore in 2008 to that in 2010?
Offer a very short reply. 0.87. What is the ratio of the ATMs(per 100,000 adults) of Turkey in 2008 to that in 2010?
Your answer should be very brief. 0.82. What is the ratio of the ATMs(per 100,000 adults) of Guatemala in 2008 to that in 2011?
Provide a succinct answer. 0.78. What is the ratio of the ATMs(per 100,000 adults) of Hungary in 2008 to that in 2011?
Your answer should be very brief. 0.94. What is the ratio of the ATMs(per 100,000 adults) of Singapore in 2008 to that in 2011?
Offer a very short reply. 0.87. What is the ratio of the ATMs(per 100,000 adults) of Turkey in 2008 to that in 2011?
Offer a very short reply. 0.73. What is the ratio of the ATMs(per 100,000 adults) of Guatemala in 2008 to that in 2012?
Provide a succinct answer. 0.76. What is the ratio of the ATMs(per 100,000 adults) in Hungary in 2008 to that in 2012?
Keep it short and to the point. 0.96. What is the ratio of the ATMs(per 100,000 adults) of Singapore in 2008 to that in 2012?
Your response must be concise. 0.87. What is the ratio of the ATMs(per 100,000 adults) in Turkey in 2008 to that in 2012?
Provide a short and direct response. 0.68. What is the ratio of the ATMs(per 100,000 adults) in Guatemala in 2008 to that in 2013?
Offer a very short reply. 0.63. What is the ratio of the ATMs(per 100,000 adults) of Hungary in 2008 to that in 2013?
Ensure brevity in your answer.  0.95. What is the ratio of the ATMs(per 100,000 adults) in Singapore in 2008 to that in 2013?
Provide a short and direct response. 0.89. What is the ratio of the ATMs(per 100,000 adults) in Turkey in 2008 to that in 2013?
Ensure brevity in your answer.  0.6. What is the ratio of the ATMs(per 100,000 adults) of Guatemala in 2008 to that in 2014?
Your answer should be compact. 0.59. What is the ratio of the ATMs(per 100,000 adults) in Hungary in 2008 to that in 2014?
Offer a very short reply. 0.93. What is the ratio of the ATMs(per 100,000 adults) of Singapore in 2008 to that in 2014?
Provide a short and direct response. 0.85. What is the ratio of the ATMs(per 100,000 adults) in Turkey in 2008 to that in 2014?
Provide a succinct answer. 0.56. What is the ratio of the ATMs(per 100,000 adults) in Guatemala in 2009 to that in 2010?
Offer a terse response. 0.91. What is the ratio of the ATMs(per 100,000 adults) of Hungary in 2009 to that in 2010?
Provide a succinct answer. 0.98. What is the ratio of the ATMs(per 100,000 adults) of Singapore in 2009 to that in 2010?
Your response must be concise. 0.9. What is the ratio of the ATMs(per 100,000 adults) in Turkey in 2009 to that in 2010?
Provide a short and direct response. 0.88. What is the ratio of the ATMs(per 100,000 adults) in Guatemala in 2009 to that in 2011?
Offer a terse response. 0.85. What is the ratio of the ATMs(per 100,000 adults) of Hungary in 2009 to that in 2011?
Your response must be concise. 0.96. What is the ratio of the ATMs(per 100,000 adults) of Singapore in 2009 to that in 2011?
Make the answer very short. 0.89. What is the ratio of the ATMs(per 100,000 adults) in Turkey in 2009 to that in 2011?
Your response must be concise. 0.78. What is the ratio of the ATMs(per 100,000 adults) in Guatemala in 2009 to that in 2012?
Your answer should be compact. 0.83. What is the ratio of the ATMs(per 100,000 adults) of Hungary in 2009 to that in 2012?
Your answer should be very brief. 0.98. What is the ratio of the ATMs(per 100,000 adults) in Singapore in 2009 to that in 2012?
Offer a very short reply. 0.9. What is the ratio of the ATMs(per 100,000 adults) in Turkey in 2009 to that in 2012?
Keep it short and to the point. 0.73. What is the ratio of the ATMs(per 100,000 adults) of Guatemala in 2009 to that in 2013?
Your response must be concise. 0.68. What is the ratio of the ATMs(per 100,000 adults) in Singapore in 2009 to that in 2013?
Keep it short and to the point. 0.92. What is the ratio of the ATMs(per 100,000 adults) of Turkey in 2009 to that in 2013?
Offer a terse response. 0.64. What is the ratio of the ATMs(per 100,000 adults) in Guatemala in 2009 to that in 2014?
Make the answer very short. 0.65. What is the ratio of the ATMs(per 100,000 adults) of Hungary in 2009 to that in 2014?
Make the answer very short. 0.96. What is the ratio of the ATMs(per 100,000 adults) in Singapore in 2009 to that in 2014?
Provide a succinct answer. 0.88. What is the ratio of the ATMs(per 100,000 adults) in Turkey in 2009 to that in 2014?
Provide a short and direct response. 0.6. What is the ratio of the ATMs(per 100,000 adults) of Guatemala in 2010 to that in 2011?
Give a very brief answer. 0.93. What is the ratio of the ATMs(per 100,000 adults) in Hungary in 2010 to that in 2011?
Give a very brief answer. 0.98. What is the ratio of the ATMs(per 100,000 adults) of Singapore in 2010 to that in 2011?
Provide a succinct answer. 0.99. What is the ratio of the ATMs(per 100,000 adults) of Turkey in 2010 to that in 2011?
Your answer should be compact. 0.89. What is the ratio of the ATMs(per 100,000 adults) of Guatemala in 2010 to that in 2012?
Your answer should be compact. 0.91. What is the ratio of the ATMs(per 100,000 adults) of Hungary in 2010 to that in 2012?
Make the answer very short. 1. What is the ratio of the ATMs(per 100,000 adults) of Singapore in 2010 to that in 2012?
Offer a terse response. 1. What is the ratio of the ATMs(per 100,000 adults) in Turkey in 2010 to that in 2012?
Provide a succinct answer. 0.82. What is the ratio of the ATMs(per 100,000 adults) in Guatemala in 2010 to that in 2013?
Ensure brevity in your answer.  0.75. What is the ratio of the ATMs(per 100,000 adults) in Hungary in 2010 to that in 2013?
Your answer should be very brief. 0.99. What is the ratio of the ATMs(per 100,000 adults) of Singapore in 2010 to that in 2013?
Your answer should be very brief. 1.02. What is the ratio of the ATMs(per 100,000 adults) of Turkey in 2010 to that in 2013?
Keep it short and to the point. 0.72. What is the ratio of the ATMs(per 100,000 adults) in Guatemala in 2010 to that in 2014?
Your answer should be very brief. 0.71. What is the ratio of the ATMs(per 100,000 adults) of Hungary in 2010 to that in 2014?
Your response must be concise. 0.97. What is the ratio of the ATMs(per 100,000 adults) in Singapore in 2010 to that in 2014?
Your response must be concise. 0.98. What is the ratio of the ATMs(per 100,000 adults) of Turkey in 2010 to that in 2014?
Your response must be concise. 0.68. What is the ratio of the ATMs(per 100,000 adults) in Guatemala in 2011 to that in 2012?
Offer a terse response. 0.98. What is the ratio of the ATMs(per 100,000 adults) in Hungary in 2011 to that in 2012?
Keep it short and to the point. 1.02. What is the ratio of the ATMs(per 100,000 adults) of Singapore in 2011 to that in 2012?
Offer a terse response. 1.01. What is the ratio of the ATMs(per 100,000 adults) of Turkey in 2011 to that in 2012?
Provide a succinct answer. 0.93. What is the ratio of the ATMs(per 100,000 adults) in Guatemala in 2011 to that in 2013?
Your response must be concise. 0.81. What is the ratio of the ATMs(per 100,000 adults) in Singapore in 2011 to that in 2013?
Make the answer very short. 1.03. What is the ratio of the ATMs(per 100,000 adults) of Turkey in 2011 to that in 2013?
Your answer should be compact. 0.82. What is the ratio of the ATMs(per 100,000 adults) of Guatemala in 2011 to that in 2014?
Your answer should be compact. 0.76. What is the ratio of the ATMs(per 100,000 adults) in Hungary in 2011 to that in 2014?
Make the answer very short. 0.99. What is the ratio of the ATMs(per 100,000 adults) of Singapore in 2011 to that in 2014?
Provide a succinct answer. 0.99. What is the ratio of the ATMs(per 100,000 adults) of Turkey in 2011 to that in 2014?
Your answer should be compact. 0.76. What is the ratio of the ATMs(per 100,000 adults) of Guatemala in 2012 to that in 2013?
Your answer should be compact. 0.82. What is the ratio of the ATMs(per 100,000 adults) of Hungary in 2012 to that in 2013?
Offer a terse response. 0.99. What is the ratio of the ATMs(per 100,000 adults) of Singapore in 2012 to that in 2013?
Your answer should be compact. 1.02. What is the ratio of the ATMs(per 100,000 adults) in Turkey in 2012 to that in 2013?
Offer a very short reply. 0.88. What is the ratio of the ATMs(per 100,000 adults) in Guatemala in 2012 to that in 2014?
Offer a terse response. 0.78. What is the ratio of the ATMs(per 100,000 adults) of Hungary in 2012 to that in 2014?
Keep it short and to the point. 0.97. What is the ratio of the ATMs(per 100,000 adults) in Singapore in 2012 to that in 2014?
Ensure brevity in your answer.  0.98. What is the ratio of the ATMs(per 100,000 adults) of Turkey in 2012 to that in 2014?
Offer a terse response. 0.82. What is the ratio of the ATMs(per 100,000 adults) of Guatemala in 2013 to that in 2014?
Provide a short and direct response. 0.94. What is the ratio of the ATMs(per 100,000 adults) of Hungary in 2013 to that in 2014?
Your response must be concise. 0.99. What is the ratio of the ATMs(per 100,000 adults) of Singapore in 2013 to that in 2014?
Ensure brevity in your answer.  0.96. What is the ratio of the ATMs(per 100,000 adults) in Turkey in 2013 to that in 2014?
Make the answer very short. 0.93. What is the difference between the highest and the second highest ATMs(per 100,000 adults) of Guatemala?
Make the answer very short. 1.98. What is the difference between the highest and the second highest ATMs(per 100,000 adults) of Hungary?
Give a very brief answer. 0.41. What is the difference between the highest and the second highest ATMs(per 100,000 adults) in Singapore?
Offer a very short reply. 0.69. What is the difference between the highest and the second highest ATMs(per 100,000 adults) of Turkey?
Keep it short and to the point. 5.08. What is the difference between the highest and the lowest ATMs(per 100,000 adults) in Guatemala?
Offer a very short reply. 14.63. What is the difference between the highest and the lowest ATMs(per 100,000 adults) in Hungary?
Your response must be concise. 3.93. What is the difference between the highest and the lowest ATMs(per 100,000 adults) in Singapore?
Your answer should be very brief. 8.6. What is the difference between the highest and the lowest ATMs(per 100,000 adults) of Turkey?
Your answer should be very brief. 34.11. 